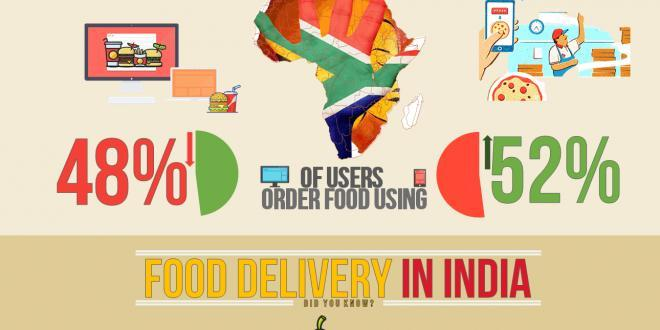What is the percentage drop of users in India who order food online using PC or laptops?
Answer the question with a short phrase. 48% What is the percentage increase of users in India who order food online through mobile phones? 52% 